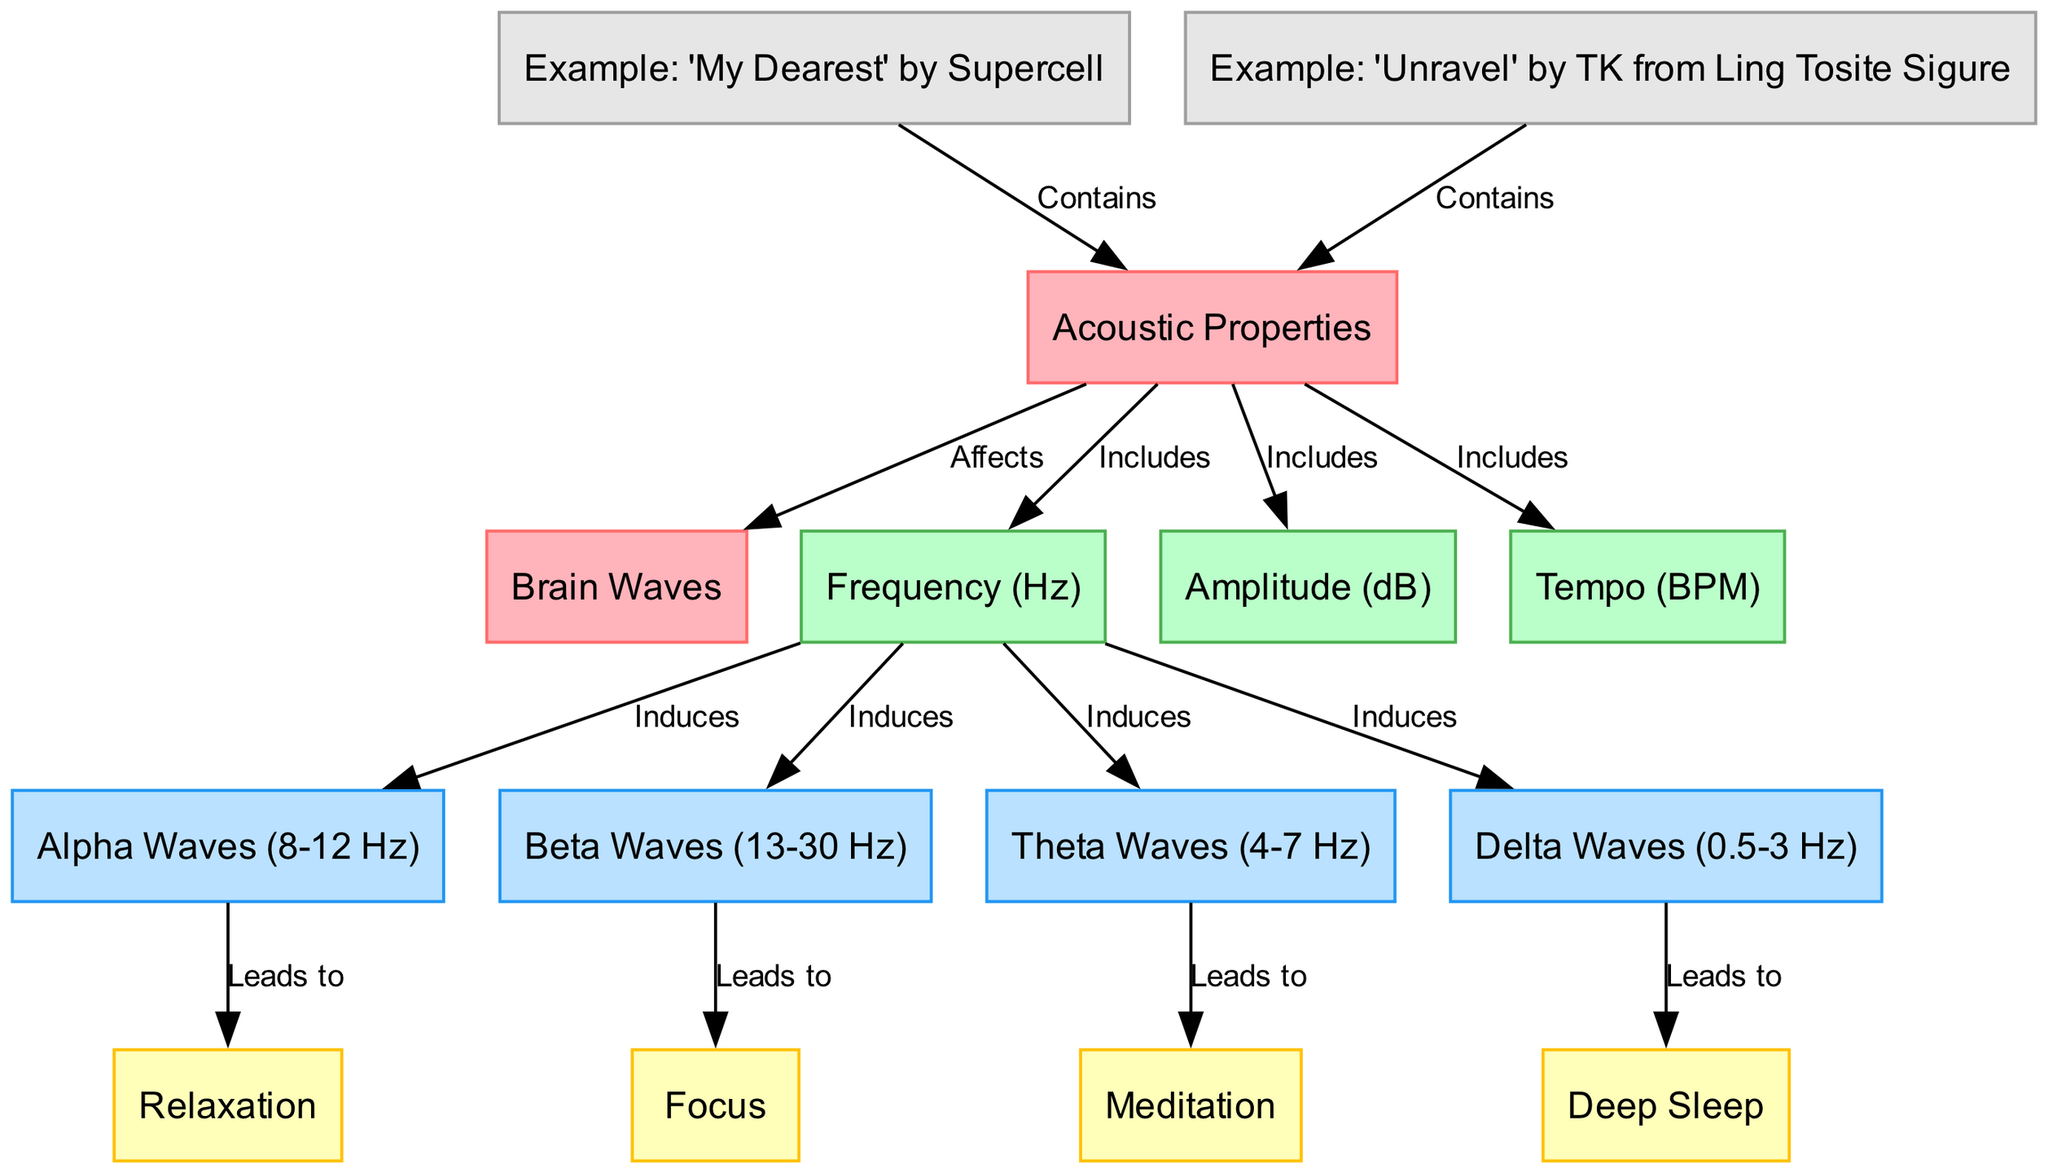What are the categories of brain waves shown in the diagram? The diagram includes Alpha Waves, Beta Waves, Theta Waves, and Delta Waves, which are clearly labeled as the nodes corresponding to brain wave states.
Answer: Alpha Waves, Beta Waves, Theta Waves, Delta Waves How many total nodes are there in the diagram? There are 15 nodes in the diagram, counting all the acoustic properties and the brain waves, as well as example soundtracks.
Answer: 15 What acoustic property is linked to inducing Delta Waves? Delta Waves are induced by frequency, as shown by the directed edge connecting Frequency (Hz) to Delta Waves (0.5-3 Hz).
Answer: Frequency (Hz) Which brain wave leads to the state of Focus? Beta Waves lead to the state of Focus, indicated by the edge going from Beta Waves to Focus in the diagram.
Answer: Beta Waves What examples of anime soundtracks are presented in the diagram? The diagram mentions two examples: "My Dearest" by Supercell and "Unravel" by TK from Ling Tosite Sigure, connected to Acoustic Properties as having specific parts of their music that contain relevant acoustic features.
Answer: "My Dearest" by Supercell, "Unravel" by TK from Ling Tosite Sigure What are the effects of Alpha Waves on brain activity? Alpha Waves lead to Relaxation, as depicted by an edge from Alpha Waves to the Relaxation node in the diagram.
Answer: Relaxation How does Frequency (Hz) influence brain waves according to the diagram? Frequency (Hz) induces various brain waves, including Alpha, Beta, Theta, and Delta Waves, as shown by the four directed edges extending from Frequency (Hz) to each wave type.
Answer: Induces Alpha, Beta, Theta, Delta Waves Which acoustic property is associated with Tempo in the diagram? Tempo is included as one of the acoustic properties, indicating it plays a role in influencing the brain waves, as evidenced by its direct connection.
Answer: Tempo (BPM) What is the relationship between Theta Waves and the process of Meditation? Theta Waves lead to the state of Meditation as indicated by the directional edge connecting Theta Waves to Meditation in the diagram.
Answer: Leads to Meditation 